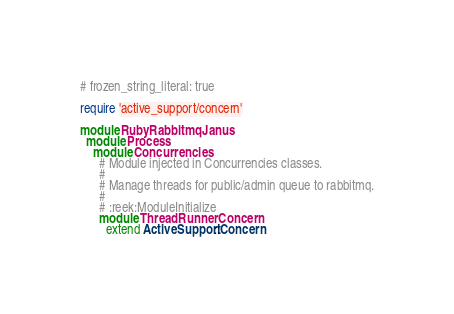<code> <loc_0><loc_0><loc_500><loc_500><_Ruby_># frozen_string_literal: true

require 'active_support/concern'

module RubyRabbitmqJanus
  module Process
    module Concurrencies
      # Module injected in Concurrencies classes.
      #
      # Manage threads for public/admin queue to rabbitmq.
      #
      # :reek:ModuleInitialize
      module ThreadRunnerConcern
        extend ActiveSupport::Concern
</code> 